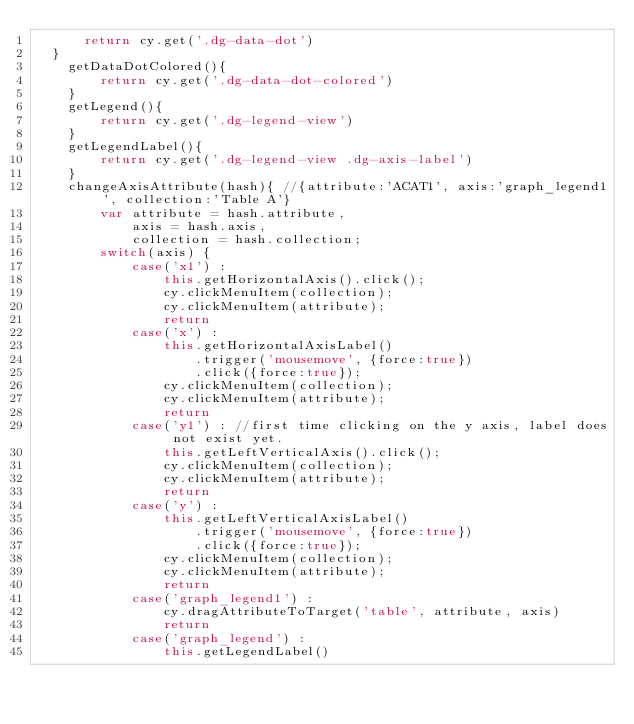<code> <loc_0><loc_0><loc_500><loc_500><_JavaScript_>      return cy.get('.dg-data-dot')
  }
    getDataDotColored(){
        return cy.get('.dg-data-dot-colored')
    }
    getLegend(){
        return cy.get('.dg-legend-view')
    }
    getLegendLabel(){
        return cy.get('.dg-legend-view .dg-axis-label')
    }
    changeAxisAttribute(hash){ //{attribute:'ACAT1', axis:'graph_legend1', collection:'Table A'}
        var attribute = hash.attribute,
            axis = hash.axis,
            collection = hash.collection;
        switch(axis) {
            case('x1') :
                this.getHorizontalAxis().click();
                cy.clickMenuItem(collection);
                cy.clickMenuItem(attribute);
                return
            case('x') :
                this.getHorizontalAxisLabel()
                    .trigger('mousemove', {force:true})
                    .click({force:true});
                cy.clickMenuItem(collection);
                cy.clickMenuItem(attribute);
                return
            case('y1') : //first time clicking on the y axis, label does not exist yet.
                this.getLeftVerticalAxis().click();
                cy.clickMenuItem(collection);
                cy.clickMenuItem(attribute);
                return
            case('y') :
                this.getLeftVerticalAxisLabel()
                    .trigger('mousemove', {force:true})
                    .click({force:true});
                cy.clickMenuItem(collection);
                cy.clickMenuItem(attribute);
                return
            case('graph_legend1') :
                cy.dragAttributeToTarget('table', attribute, axis)
                return
            case('graph_legend') :
                this.getLegendLabel()</code> 